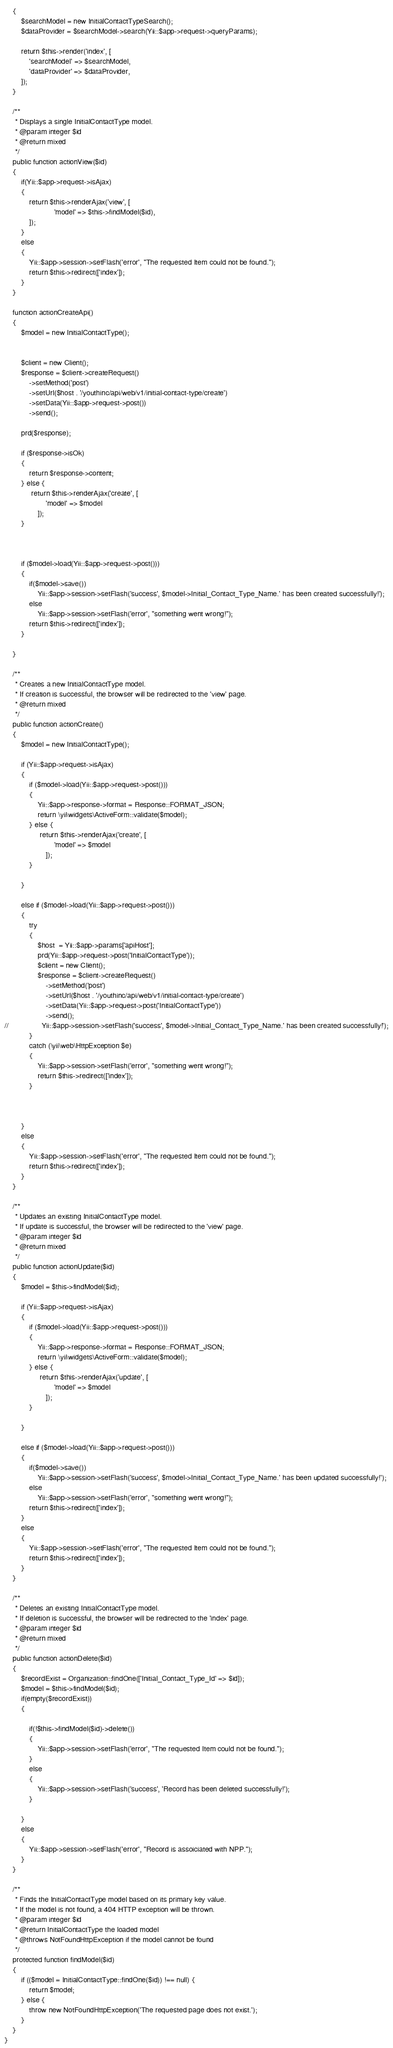<code> <loc_0><loc_0><loc_500><loc_500><_PHP_>    {
        $searchModel = new InitialContactTypeSearch();
        $dataProvider = $searchModel->search(Yii::$app->request->queryParams);

        return $this->render('index', [
            'searchModel' => $searchModel,
            'dataProvider' => $dataProvider,
        ]);
    }

    /**
     * Displays a single InitialContactType model.
     * @param integer $id
     * @return mixed
     */
    public function actionView($id)
    {
        if(Yii::$app->request->isAjax)
        {
            return $this->renderAjax('view', [
                        'model' => $this->findModel($id),
            ]);
        }
        else
        {
            Yii::$app->session->setFlash('error', "The requested Item could not be found.");
            return $this->redirect(['index']);
        }
    }

    function actionCreateApi()
    {
        $model = new InitialContactType();

        
        $client = new Client();
        $response = $client->createRequest()
            ->setMethod('post')
            ->setUrl($host . '/youthinc/api/web/v1/initial-contact-type/create')
            ->setData(Yii::$app->request->post())
            ->send();

        prd($response);

        if ($response->isOk) 
        {
            return $response->content;
        } else {
             return $this->renderAjax('create', [
                    'model' => $model
                ]);
        }
           
        
        
        if ($model->load(Yii::$app->request->post())) 
        {
            if($model->save())
                Yii::$app->session->setFlash('success', $model->Initial_Contact_Type_Name.' has been created successfully!');
            else
                Yii::$app->session->setFlash('error', "something went wrong!");
            return $this->redirect(['index']);
        } 
        
    }
    
    /**
     * Creates a new InitialContactType model.
     * If creation is successful, the browser will be redirected to the 'view' page.
     * @return mixed
     */
    public function actionCreate()
    {
        $model = new InitialContactType();

        if (Yii::$app->request->isAjax) 
        {
            if ($model->load(Yii::$app->request->post())) 
            {
                Yii::$app->response->format = Response::FORMAT_JSON;
                return \yii\widgets\ActiveForm::validate($model);
            } else {
                 return $this->renderAjax('create', [
                        'model' => $model
                    ]);
            }
           
        }
        
        else if ($model->load(Yii::$app->request->post())) 
        {
            try
            {
                $host  = Yii::$app->params['apiHost'];
                prd(Yii::$app->request->post('InitialContactType'));
                $client = new Client();
                $response = $client->createRequest()
                    ->setMethod('post')
                    ->setUrl($host . '/youthinc/api/web/v1/initial-contact-type/create')
                    ->setData(Yii::$app->request->post('InitialContactType'))
                    ->send();
//                Yii::$app->session->setFlash('success', $model->Initial_Contact_Type_Name.' has been created successfully!');
            }
            catch (\yii\web\HttpException $e)
            {
                Yii::$app->session->setFlash('error', "something went wrong!");
                return $this->redirect(['index']);
            }
                
            
                
        } 
        else
        {
            Yii::$app->session->setFlash('error', "The requested Item could not be found.");
            return $this->redirect(['index']);
        }
    }

    /**
     * Updates an existing InitialContactType model.
     * If update is successful, the browser will be redirected to the 'view' page.
     * @param integer $id
     * @return mixed
     */
    public function actionUpdate($id)
    {
        $model = $this->findModel($id);

        if (Yii::$app->request->isAjax) 
        {
            if ($model->load(Yii::$app->request->post())) 
            {
                Yii::$app->response->format = Response::FORMAT_JSON;
                return \yii\widgets\ActiveForm::validate($model);
            } else {
                 return $this->renderAjax('update', [
                        'model' => $model
                    ]);
            }
           
        }
        
        else if ($model->load(Yii::$app->request->post())) 
        {
            if($model->save())
                Yii::$app->session->setFlash('success', $model->Initial_Contact_Type_Name.' has been updated successfully!');
            else
                Yii::$app->session->setFlash('error', "something went wrong!");
            return $this->redirect(['index']);
        } 
        else
        {
            Yii::$app->session->setFlash('error', "The requested Item could not be found.");
            return $this->redirect(['index']);
        }
    }

    /**
     * Deletes an existing InitialContactType model.
     * If deletion is successful, the browser will be redirected to the 'index' page.
     * @param integer $id
     * @return mixed
     */
    public function actionDelete($id)
    {
        $recordExist = Organization::findOne(['Initial_Contact_Type_Id' => $id]);
        $model = $this->findModel($id);  
        if(empty($recordExist))
        {
            
            if(!$this->findModel($id)->delete())
            {
                Yii::$app->session->setFlash('error', "The requested Item could not be found.");
            }
            else
            {
                Yii::$app->session->setFlash('success', 'Record has been deleted successfully!');
            }
            
        }
        else
        {
            Yii::$app->session->setFlash('error', "Record is assoiciated with NPP.");
        }
    }

    /**
     * Finds the InitialContactType model based on its primary key value.
     * If the model is not found, a 404 HTTP exception will be thrown.
     * @param integer $id
     * @return InitialContactType the loaded model
     * @throws NotFoundHttpException if the model cannot be found
     */
    protected function findModel($id)
    {
        if (($model = InitialContactType::findOne($id)) !== null) {
            return $model;
        } else {
            throw new NotFoundHttpException('The requested page does not exist.');
        }
    }
}
</code> 